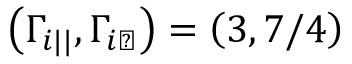<formula> <loc_0><loc_0><loc_500><loc_500>\left ( \Gamma _ { i | | } , \Gamma _ { i \perp } \right ) = \left ( 3 , 7 / 4 \right )</formula> 